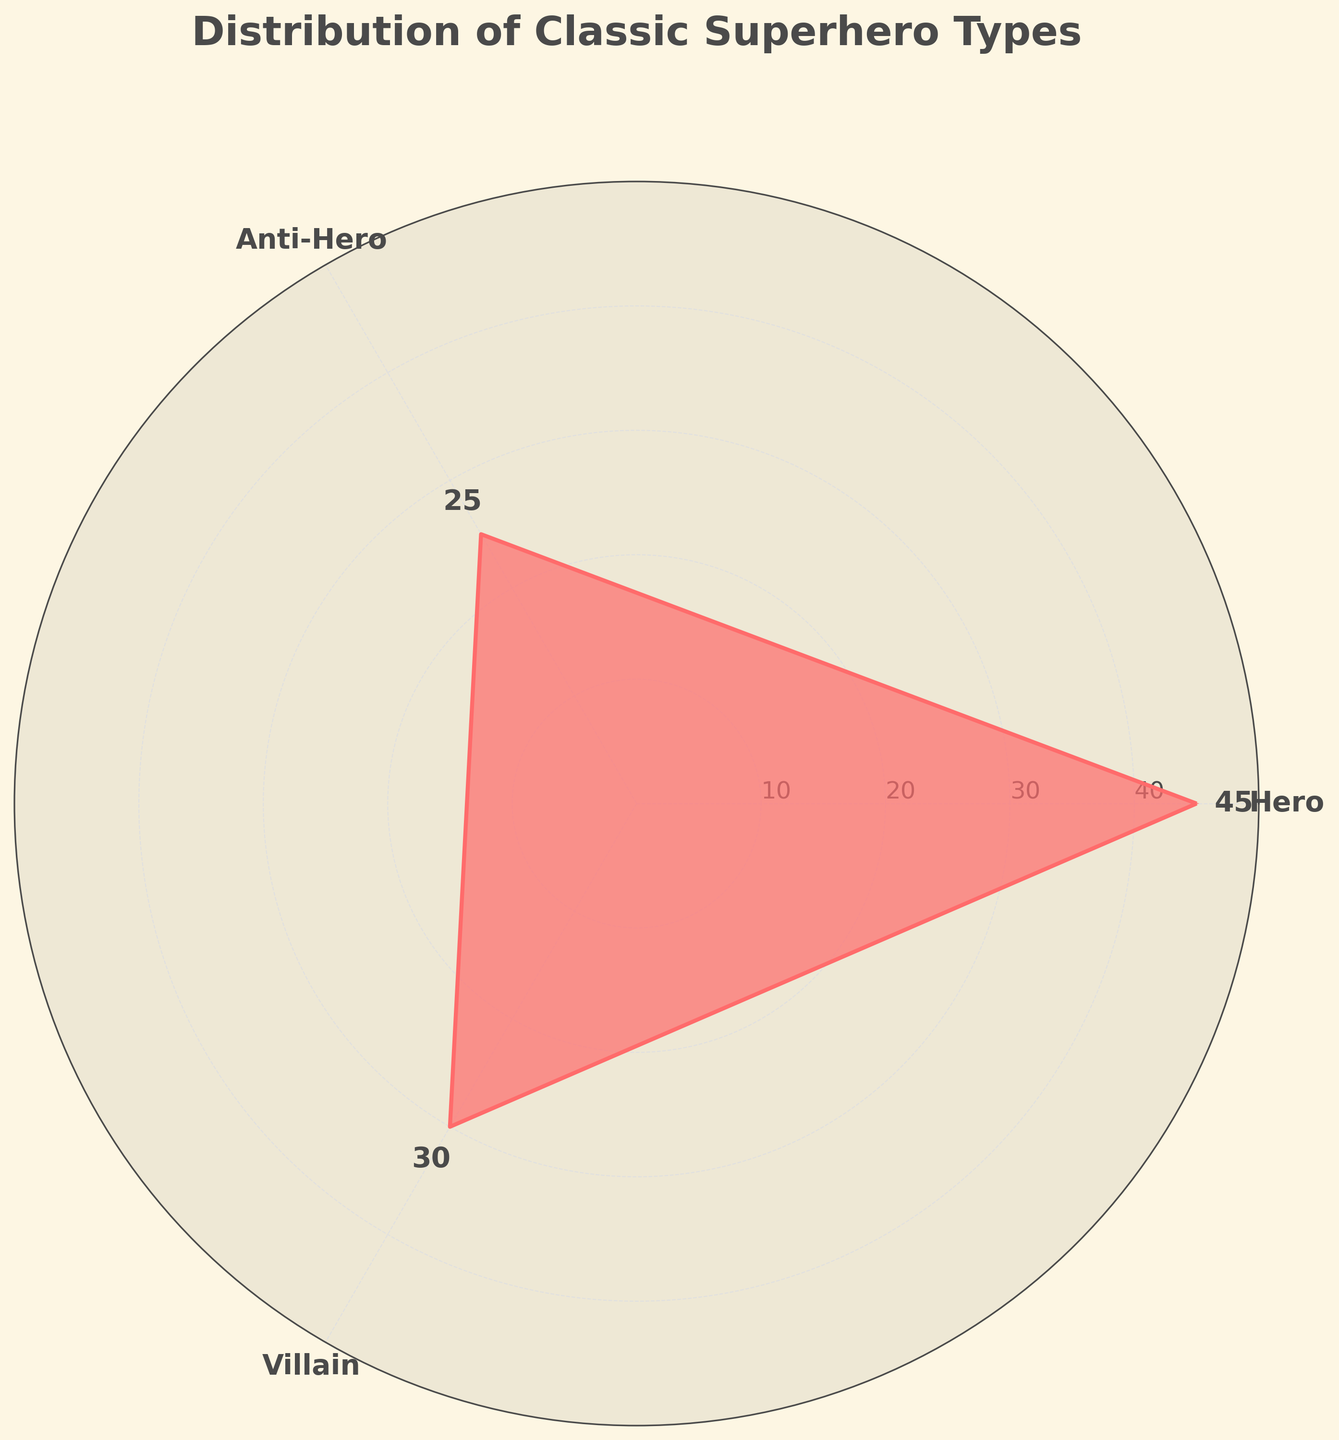Which superhero type has the highest count? The Hero section has the highest value on the chart, shown by the longest radial line and the highest count of 45.
Answer: Hero What is the title of the chart? The title of the chart is usually displayed at the top. In this chart, it is "Distribution of Classic Superhero Types".
Answer: Distribution of Classic Superhero Types How many superhero categories are represented in the chart? The chart shows three distinct sections which represent three different superhero categories: Hero, Anti-Hero, and Villain.
Answer: 3 What is the total count of all classic superhero types combined? To find the total, add the counts of Heroes (45), Anti-Heroes (25), and Villains (30): 45 + 25 + 30 = 100.
Answer: 100 Which superhero type has the lowest count? The Anti-Hero section has the shortest radial line on the chart with the value of 25, indicating the lowest count.
Answer: Anti-Hero How does the count of Villains compare to the count of Anti-Heroes? The Villains section has a count of 30, which is greater than the Anti-Heroes’ count of 25.
Answer: Villains have a higher count What is the average count of Heroes and Villains? To find the average, add the counts of Heroes (45) and Villains (30) and divide by 2: (45 + 30) / 2 = 37.5.
Answer: 37.5 What angle corresponds to the Anti-Hero type in the chart? The categories are spaced equally around the circle. Since there are three categories, each occupies 120 degrees, and the Anti-Hero is located at 240 degrees (120 degrees x 2).
Answer: 240 degrees Are Villains more common than Anti-Heroes? Yes, as the Villain count (30) is greater than the Anti-Hero count (25).
Answer: Yes 